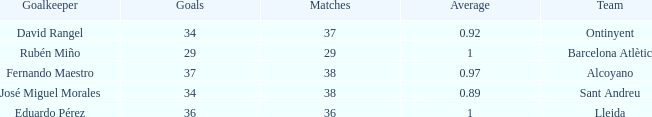What is the sum of Goals, when Matches is less than 29? None. 